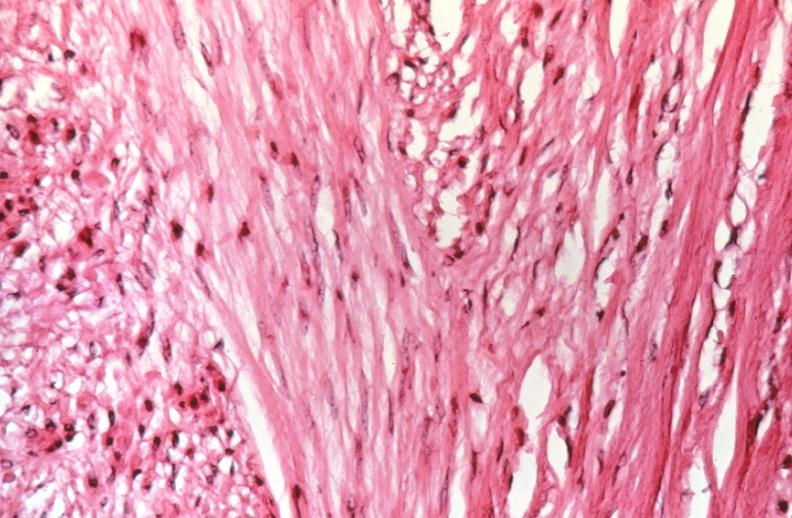what is present?
Answer the question using a single word or phrase. Female reproductive 